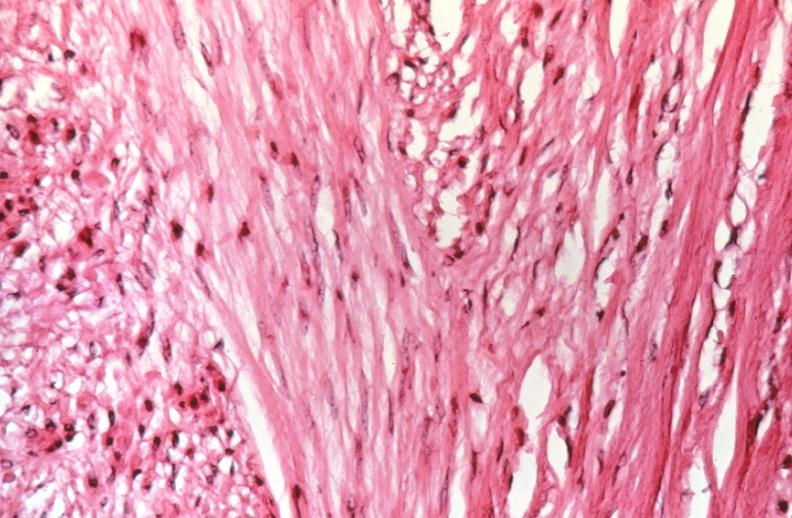what is present?
Answer the question using a single word or phrase. Female reproductive 